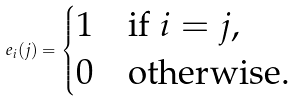<formula> <loc_0><loc_0><loc_500><loc_500>e _ { i } ( j ) = \begin{cases} 1 & \text {if $i=j$,} \\ 0 & \text {otherwise.} \end{cases}</formula> 